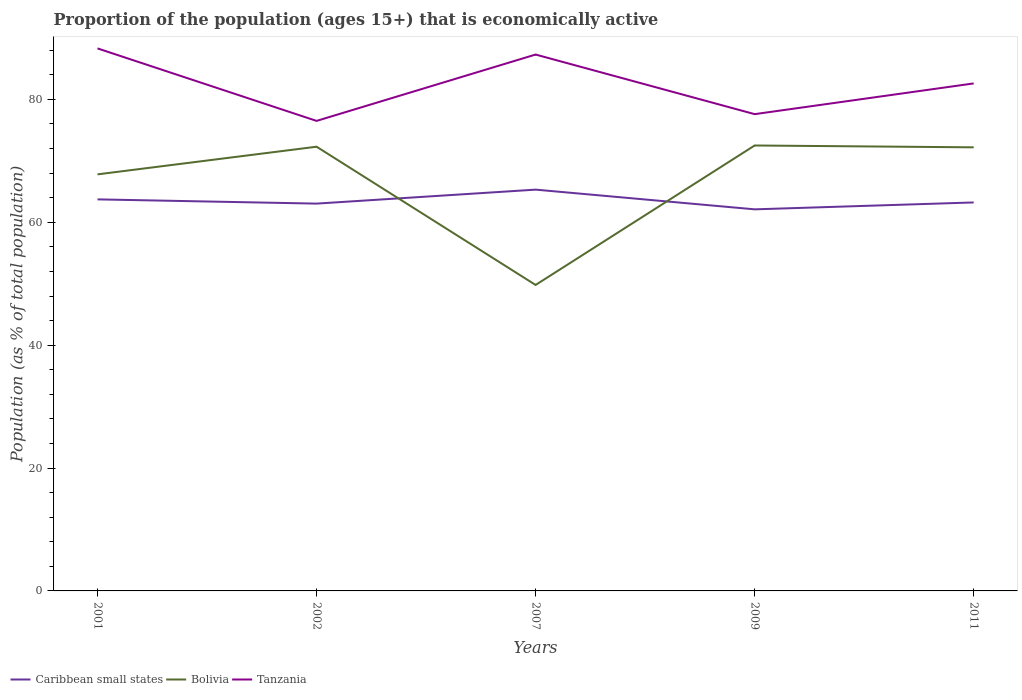How many different coloured lines are there?
Offer a terse response. 3. Does the line corresponding to Caribbean small states intersect with the line corresponding to Bolivia?
Give a very brief answer. Yes. Across all years, what is the maximum proportion of the population that is economically active in Bolivia?
Ensure brevity in your answer.  49.8. In which year was the proportion of the population that is economically active in Bolivia maximum?
Your response must be concise. 2007. What is the total proportion of the population that is economically active in Bolivia in the graph?
Ensure brevity in your answer.  -4.4. What is the difference between the highest and the second highest proportion of the population that is economically active in Caribbean small states?
Your response must be concise. 3.21. Is the proportion of the population that is economically active in Tanzania strictly greater than the proportion of the population that is economically active in Caribbean small states over the years?
Provide a succinct answer. No. What is the difference between two consecutive major ticks on the Y-axis?
Keep it short and to the point. 20. Does the graph contain grids?
Provide a succinct answer. No. How many legend labels are there?
Make the answer very short. 3. What is the title of the graph?
Offer a very short reply. Proportion of the population (ages 15+) that is economically active. Does "Tonga" appear as one of the legend labels in the graph?
Offer a very short reply. No. What is the label or title of the Y-axis?
Your answer should be compact. Population (as % of total population). What is the Population (as % of total population) in Caribbean small states in 2001?
Offer a very short reply. 63.73. What is the Population (as % of total population) of Bolivia in 2001?
Your answer should be compact. 67.8. What is the Population (as % of total population) of Tanzania in 2001?
Provide a short and direct response. 88.3. What is the Population (as % of total population) of Caribbean small states in 2002?
Provide a succinct answer. 63.04. What is the Population (as % of total population) of Bolivia in 2002?
Your answer should be very brief. 72.3. What is the Population (as % of total population) of Tanzania in 2002?
Provide a succinct answer. 76.5. What is the Population (as % of total population) of Caribbean small states in 2007?
Make the answer very short. 65.31. What is the Population (as % of total population) in Bolivia in 2007?
Give a very brief answer. 49.8. What is the Population (as % of total population) in Tanzania in 2007?
Provide a succinct answer. 87.3. What is the Population (as % of total population) of Caribbean small states in 2009?
Your response must be concise. 62.11. What is the Population (as % of total population) of Bolivia in 2009?
Ensure brevity in your answer.  72.5. What is the Population (as % of total population) of Tanzania in 2009?
Provide a succinct answer. 77.6. What is the Population (as % of total population) of Caribbean small states in 2011?
Provide a succinct answer. 63.23. What is the Population (as % of total population) in Bolivia in 2011?
Your answer should be compact. 72.2. What is the Population (as % of total population) in Tanzania in 2011?
Provide a short and direct response. 82.6. Across all years, what is the maximum Population (as % of total population) of Caribbean small states?
Your answer should be very brief. 65.31. Across all years, what is the maximum Population (as % of total population) of Bolivia?
Your answer should be very brief. 72.5. Across all years, what is the maximum Population (as % of total population) of Tanzania?
Offer a very short reply. 88.3. Across all years, what is the minimum Population (as % of total population) in Caribbean small states?
Make the answer very short. 62.11. Across all years, what is the minimum Population (as % of total population) of Bolivia?
Make the answer very short. 49.8. Across all years, what is the minimum Population (as % of total population) of Tanzania?
Keep it short and to the point. 76.5. What is the total Population (as % of total population) of Caribbean small states in the graph?
Make the answer very short. 317.41. What is the total Population (as % of total population) of Bolivia in the graph?
Provide a succinct answer. 334.6. What is the total Population (as % of total population) of Tanzania in the graph?
Your response must be concise. 412.3. What is the difference between the Population (as % of total population) of Caribbean small states in 2001 and that in 2002?
Your response must be concise. 0.69. What is the difference between the Population (as % of total population) in Bolivia in 2001 and that in 2002?
Your answer should be compact. -4.5. What is the difference between the Population (as % of total population) in Caribbean small states in 2001 and that in 2007?
Your answer should be compact. -1.59. What is the difference between the Population (as % of total population) in Bolivia in 2001 and that in 2007?
Offer a very short reply. 18. What is the difference between the Population (as % of total population) of Caribbean small states in 2001 and that in 2009?
Provide a short and direct response. 1.62. What is the difference between the Population (as % of total population) of Bolivia in 2001 and that in 2009?
Offer a terse response. -4.7. What is the difference between the Population (as % of total population) of Caribbean small states in 2001 and that in 2011?
Offer a very short reply. 0.5. What is the difference between the Population (as % of total population) of Caribbean small states in 2002 and that in 2007?
Your answer should be very brief. -2.27. What is the difference between the Population (as % of total population) of Tanzania in 2002 and that in 2007?
Keep it short and to the point. -10.8. What is the difference between the Population (as % of total population) of Caribbean small states in 2002 and that in 2009?
Provide a short and direct response. 0.93. What is the difference between the Population (as % of total population) in Caribbean small states in 2002 and that in 2011?
Keep it short and to the point. -0.19. What is the difference between the Population (as % of total population) in Tanzania in 2002 and that in 2011?
Provide a succinct answer. -6.1. What is the difference between the Population (as % of total population) of Caribbean small states in 2007 and that in 2009?
Offer a terse response. 3.21. What is the difference between the Population (as % of total population) of Bolivia in 2007 and that in 2009?
Your response must be concise. -22.7. What is the difference between the Population (as % of total population) of Caribbean small states in 2007 and that in 2011?
Ensure brevity in your answer.  2.08. What is the difference between the Population (as % of total population) of Bolivia in 2007 and that in 2011?
Make the answer very short. -22.4. What is the difference between the Population (as % of total population) in Tanzania in 2007 and that in 2011?
Provide a succinct answer. 4.7. What is the difference between the Population (as % of total population) in Caribbean small states in 2009 and that in 2011?
Your answer should be very brief. -1.12. What is the difference between the Population (as % of total population) in Tanzania in 2009 and that in 2011?
Ensure brevity in your answer.  -5. What is the difference between the Population (as % of total population) in Caribbean small states in 2001 and the Population (as % of total population) in Bolivia in 2002?
Provide a short and direct response. -8.57. What is the difference between the Population (as % of total population) in Caribbean small states in 2001 and the Population (as % of total population) in Tanzania in 2002?
Your answer should be very brief. -12.77. What is the difference between the Population (as % of total population) of Caribbean small states in 2001 and the Population (as % of total population) of Bolivia in 2007?
Offer a terse response. 13.93. What is the difference between the Population (as % of total population) of Caribbean small states in 2001 and the Population (as % of total population) of Tanzania in 2007?
Give a very brief answer. -23.57. What is the difference between the Population (as % of total population) in Bolivia in 2001 and the Population (as % of total population) in Tanzania in 2007?
Provide a succinct answer. -19.5. What is the difference between the Population (as % of total population) of Caribbean small states in 2001 and the Population (as % of total population) of Bolivia in 2009?
Provide a short and direct response. -8.77. What is the difference between the Population (as % of total population) of Caribbean small states in 2001 and the Population (as % of total population) of Tanzania in 2009?
Provide a succinct answer. -13.87. What is the difference between the Population (as % of total population) of Bolivia in 2001 and the Population (as % of total population) of Tanzania in 2009?
Your response must be concise. -9.8. What is the difference between the Population (as % of total population) of Caribbean small states in 2001 and the Population (as % of total population) of Bolivia in 2011?
Provide a succinct answer. -8.47. What is the difference between the Population (as % of total population) in Caribbean small states in 2001 and the Population (as % of total population) in Tanzania in 2011?
Your answer should be compact. -18.87. What is the difference between the Population (as % of total population) of Bolivia in 2001 and the Population (as % of total population) of Tanzania in 2011?
Provide a succinct answer. -14.8. What is the difference between the Population (as % of total population) in Caribbean small states in 2002 and the Population (as % of total population) in Bolivia in 2007?
Give a very brief answer. 13.24. What is the difference between the Population (as % of total population) of Caribbean small states in 2002 and the Population (as % of total population) of Tanzania in 2007?
Your answer should be very brief. -24.26. What is the difference between the Population (as % of total population) in Bolivia in 2002 and the Population (as % of total population) in Tanzania in 2007?
Provide a succinct answer. -15. What is the difference between the Population (as % of total population) of Caribbean small states in 2002 and the Population (as % of total population) of Bolivia in 2009?
Provide a succinct answer. -9.46. What is the difference between the Population (as % of total population) in Caribbean small states in 2002 and the Population (as % of total population) in Tanzania in 2009?
Make the answer very short. -14.56. What is the difference between the Population (as % of total population) in Bolivia in 2002 and the Population (as % of total population) in Tanzania in 2009?
Make the answer very short. -5.3. What is the difference between the Population (as % of total population) in Caribbean small states in 2002 and the Population (as % of total population) in Bolivia in 2011?
Make the answer very short. -9.16. What is the difference between the Population (as % of total population) of Caribbean small states in 2002 and the Population (as % of total population) of Tanzania in 2011?
Your response must be concise. -19.56. What is the difference between the Population (as % of total population) in Caribbean small states in 2007 and the Population (as % of total population) in Bolivia in 2009?
Your response must be concise. -7.19. What is the difference between the Population (as % of total population) in Caribbean small states in 2007 and the Population (as % of total population) in Tanzania in 2009?
Make the answer very short. -12.29. What is the difference between the Population (as % of total population) of Bolivia in 2007 and the Population (as % of total population) of Tanzania in 2009?
Provide a succinct answer. -27.8. What is the difference between the Population (as % of total population) in Caribbean small states in 2007 and the Population (as % of total population) in Bolivia in 2011?
Make the answer very short. -6.89. What is the difference between the Population (as % of total population) of Caribbean small states in 2007 and the Population (as % of total population) of Tanzania in 2011?
Provide a short and direct response. -17.29. What is the difference between the Population (as % of total population) of Bolivia in 2007 and the Population (as % of total population) of Tanzania in 2011?
Give a very brief answer. -32.8. What is the difference between the Population (as % of total population) of Caribbean small states in 2009 and the Population (as % of total population) of Bolivia in 2011?
Your answer should be very brief. -10.09. What is the difference between the Population (as % of total population) in Caribbean small states in 2009 and the Population (as % of total population) in Tanzania in 2011?
Keep it short and to the point. -20.49. What is the average Population (as % of total population) of Caribbean small states per year?
Provide a succinct answer. 63.48. What is the average Population (as % of total population) of Bolivia per year?
Your answer should be very brief. 66.92. What is the average Population (as % of total population) in Tanzania per year?
Your response must be concise. 82.46. In the year 2001, what is the difference between the Population (as % of total population) of Caribbean small states and Population (as % of total population) of Bolivia?
Your response must be concise. -4.07. In the year 2001, what is the difference between the Population (as % of total population) in Caribbean small states and Population (as % of total population) in Tanzania?
Your answer should be compact. -24.57. In the year 2001, what is the difference between the Population (as % of total population) of Bolivia and Population (as % of total population) of Tanzania?
Ensure brevity in your answer.  -20.5. In the year 2002, what is the difference between the Population (as % of total population) in Caribbean small states and Population (as % of total population) in Bolivia?
Make the answer very short. -9.26. In the year 2002, what is the difference between the Population (as % of total population) of Caribbean small states and Population (as % of total population) of Tanzania?
Provide a succinct answer. -13.46. In the year 2002, what is the difference between the Population (as % of total population) of Bolivia and Population (as % of total population) of Tanzania?
Your answer should be very brief. -4.2. In the year 2007, what is the difference between the Population (as % of total population) of Caribbean small states and Population (as % of total population) of Bolivia?
Provide a short and direct response. 15.51. In the year 2007, what is the difference between the Population (as % of total population) in Caribbean small states and Population (as % of total population) in Tanzania?
Keep it short and to the point. -21.99. In the year 2007, what is the difference between the Population (as % of total population) of Bolivia and Population (as % of total population) of Tanzania?
Your answer should be very brief. -37.5. In the year 2009, what is the difference between the Population (as % of total population) in Caribbean small states and Population (as % of total population) in Bolivia?
Give a very brief answer. -10.39. In the year 2009, what is the difference between the Population (as % of total population) in Caribbean small states and Population (as % of total population) in Tanzania?
Give a very brief answer. -15.49. In the year 2009, what is the difference between the Population (as % of total population) of Bolivia and Population (as % of total population) of Tanzania?
Your answer should be compact. -5.1. In the year 2011, what is the difference between the Population (as % of total population) of Caribbean small states and Population (as % of total population) of Bolivia?
Your answer should be compact. -8.97. In the year 2011, what is the difference between the Population (as % of total population) in Caribbean small states and Population (as % of total population) in Tanzania?
Ensure brevity in your answer.  -19.37. In the year 2011, what is the difference between the Population (as % of total population) of Bolivia and Population (as % of total population) of Tanzania?
Offer a terse response. -10.4. What is the ratio of the Population (as % of total population) of Caribbean small states in 2001 to that in 2002?
Offer a terse response. 1.01. What is the ratio of the Population (as % of total population) in Bolivia in 2001 to that in 2002?
Keep it short and to the point. 0.94. What is the ratio of the Population (as % of total population) of Tanzania in 2001 to that in 2002?
Provide a short and direct response. 1.15. What is the ratio of the Population (as % of total population) in Caribbean small states in 2001 to that in 2007?
Your answer should be very brief. 0.98. What is the ratio of the Population (as % of total population) in Bolivia in 2001 to that in 2007?
Ensure brevity in your answer.  1.36. What is the ratio of the Population (as % of total population) in Tanzania in 2001 to that in 2007?
Your response must be concise. 1.01. What is the ratio of the Population (as % of total population) in Caribbean small states in 2001 to that in 2009?
Provide a succinct answer. 1.03. What is the ratio of the Population (as % of total population) of Bolivia in 2001 to that in 2009?
Give a very brief answer. 0.94. What is the ratio of the Population (as % of total population) of Tanzania in 2001 to that in 2009?
Ensure brevity in your answer.  1.14. What is the ratio of the Population (as % of total population) in Caribbean small states in 2001 to that in 2011?
Your answer should be compact. 1.01. What is the ratio of the Population (as % of total population) in Bolivia in 2001 to that in 2011?
Provide a short and direct response. 0.94. What is the ratio of the Population (as % of total population) of Tanzania in 2001 to that in 2011?
Make the answer very short. 1.07. What is the ratio of the Population (as % of total population) of Caribbean small states in 2002 to that in 2007?
Provide a succinct answer. 0.97. What is the ratio of the Population (as % of total population) in Bolivia in 2002 to that in 2007?
Your answer should be very brief. 1.45. What is the ratio of the Population (as % of total population) of Tanzania in 2002 to that in 2007?
Your response must be concise. 0.88. What is the ratio of the Population (as % of total population) of Tanzania in 2002 to that in 2009?
Ensure brevity in your answer.  0.99. What is the ratio of the Population (as % of total population) in Tanzania in 2002 to that in 2011?
Your response must be concise. 0.93. What is the ratio of the Population (as % of total population) in Caribbean small states in 2007 to that in 2009?
Your answer should be very brief. 1.05. What is the ratio of the Population (as % of total population) in Bolivia in 2007 to that in 2009?
Offer a terse response. 0.69. What is the ratio of the Population (as % of total population) in Caribbean small states in 2007 to that in 2011?
Your answer should be very brief. 1.03. What is the ratio of the Population (as % of total population) of Bolivia in 2007 to that in 2011?
Your answer should be very brief. 0.69. What is the ratio of the Population (as % of total population) of Tanzania in 2007 to that in 2011?
Offer a terse response. 1.06. What is the ratio of the Population (as % of total population) of Caribbean small states in 2009 to that in 2011?
Make the answer very short. 0.98. What is the ratio of the Population (as % of total population) in Tanzania in 2009 to that in 2011?
Give a very brief answer. 0.94. What is the difference between the highest and the second highest Population (as % of total population) in Caribbean small states?
Provide a succinct answer. 1.59. What is the difference between the highest and the second highest Population (as % of total population) in Bolivia?
Provide a short and direct response. 0.2. What is the difference between the highest and the lowest Population (as % of total population) of Caribbean small states?
Give a very brief answer. 3.21. What is the difference between the highest and the lowest Population (as % of total population) of Bolivia?
Ensure brevity in your answer.  22.7. 